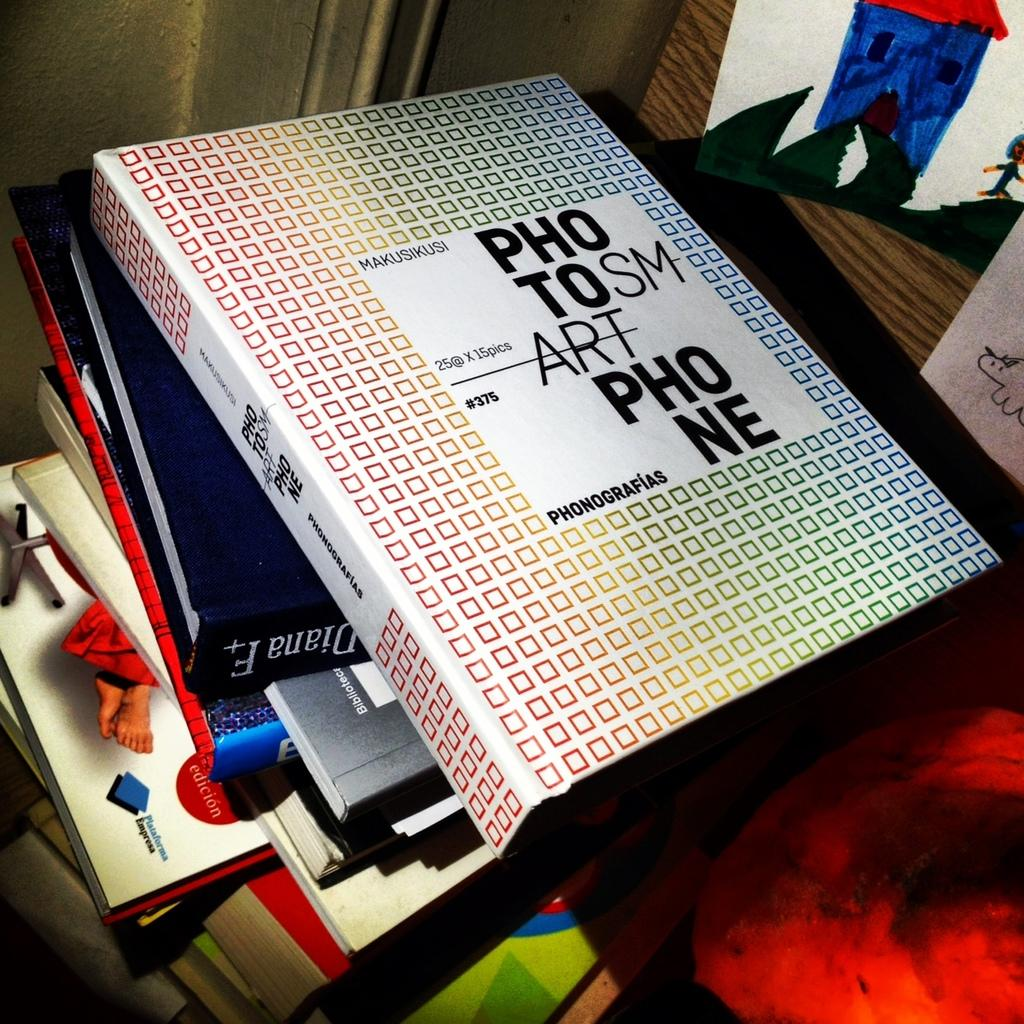<image>
Render a clear and concise summary of the photo. A binder with the words photo, smart, and pone sits on top of a stack of books. 